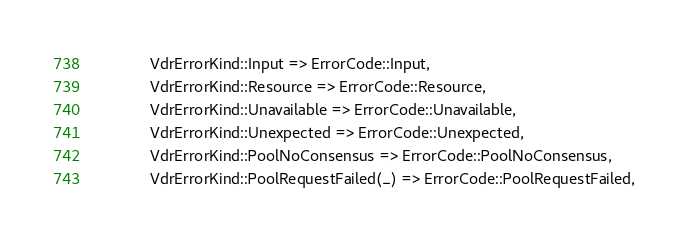Convert code to text. <code><loc_0><loc_0><loc_500><loc_500><_Rust_>            VdrErrorKind::Input => ErrorCode::Input,
            VdrErrorKind::Resource => ErrorCode::Resource,
            VdrErrorKind::Unavailable => ErrorCode::Unavailable,
            VdrErrorKind::Unexpected => ErrorCode::Unexpected,
            VdrErrorKind::PoolNoConsensus => ErrorCode::PoolNoConsensus,
            VdrErrorKind::PoolRequestFailed(_) => ErrorCode::PoolRequestFailed,</code> 